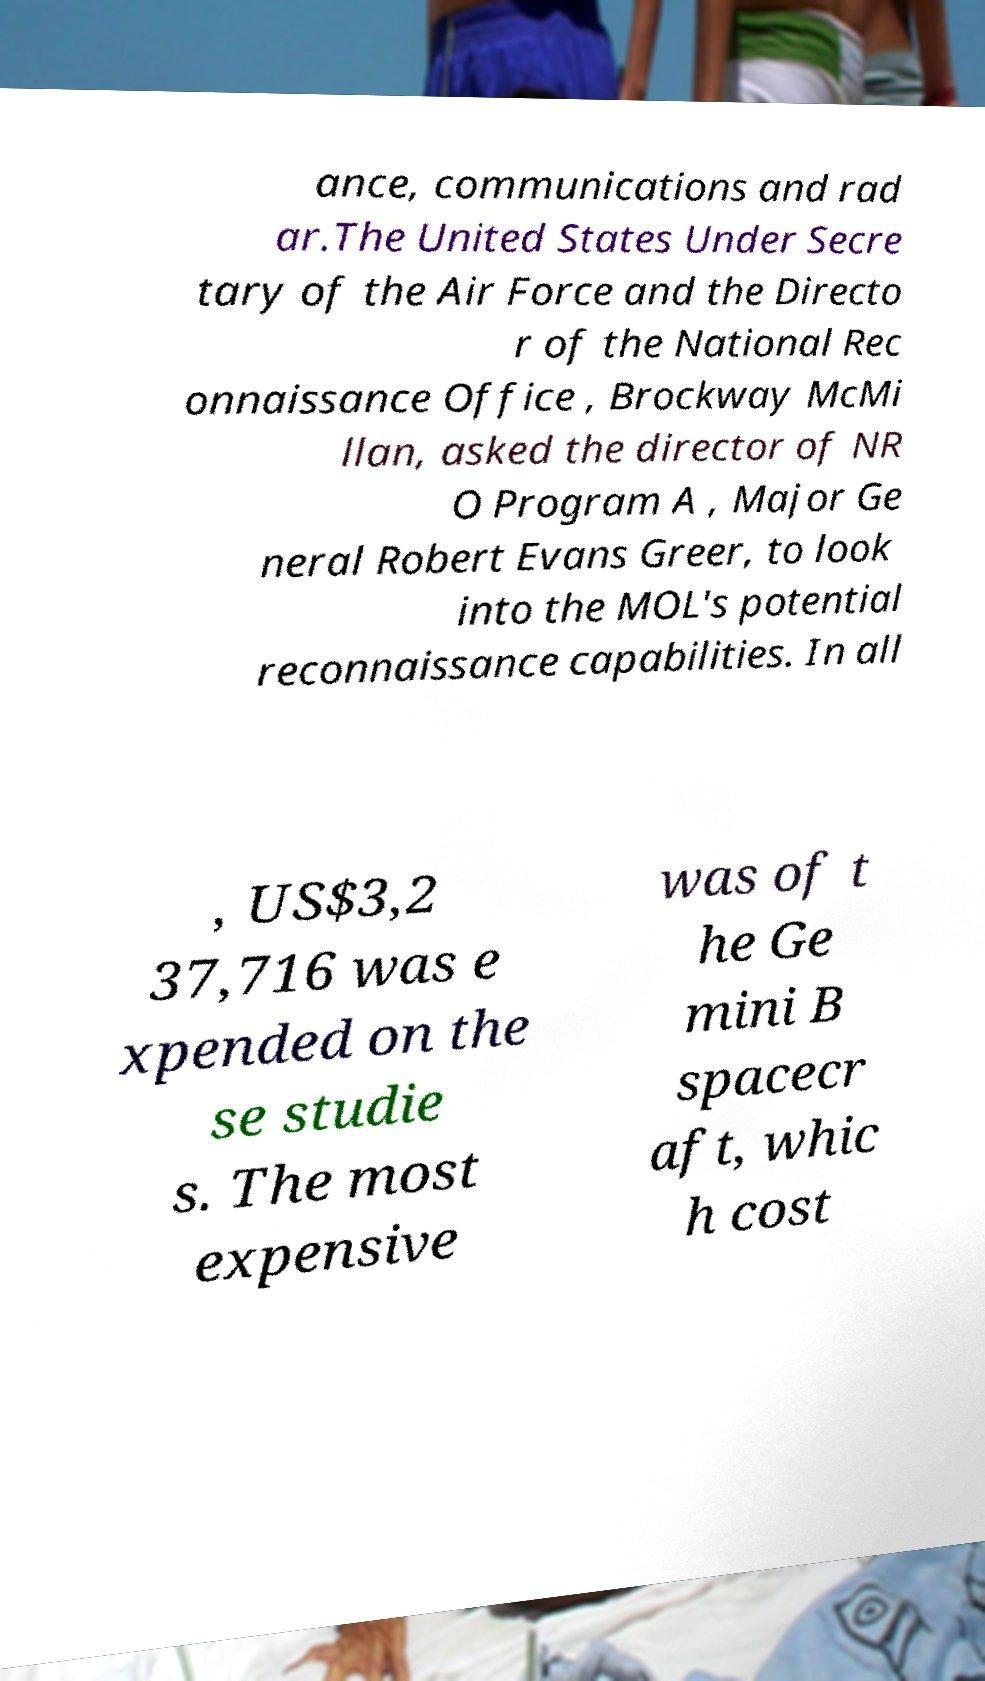Can you read and provide the text displayed in the image?This photo seems to have some interesting text. Can you extract and type it out for me? ance, communications and rad ar.The United States Under Secre tary of the Air Force and the Directo r of the National Rec onnaissance Office , Brockway McMi llan, asked the director of NR O Program A , Major Ge neral Robert Evans Greer, to look into the MOL's potential reconnaissance capabilities. In all , US$3,2 37,716 was e xpended on the se studie s. The most expensive was of t he Ge mini B spacecr aft, whic h cost 